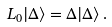<formula> <loc_0><loc_0><loc_500><loc_500>L _ { 0 } | \Delta \rangle = \Delta | \Delta \rangle \, .</formula> 